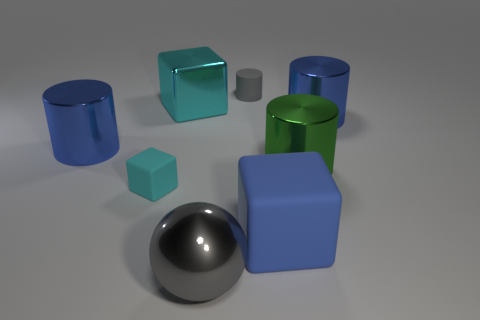Can you describe the color scheme of the image? The image showcases a relatively muted color palette with a focus on primary colors. There are blue and green objects that stand out against the neutral gray background. The sphere, with its metallic surface, adds diversity to the color scheme with its reflective nature. 